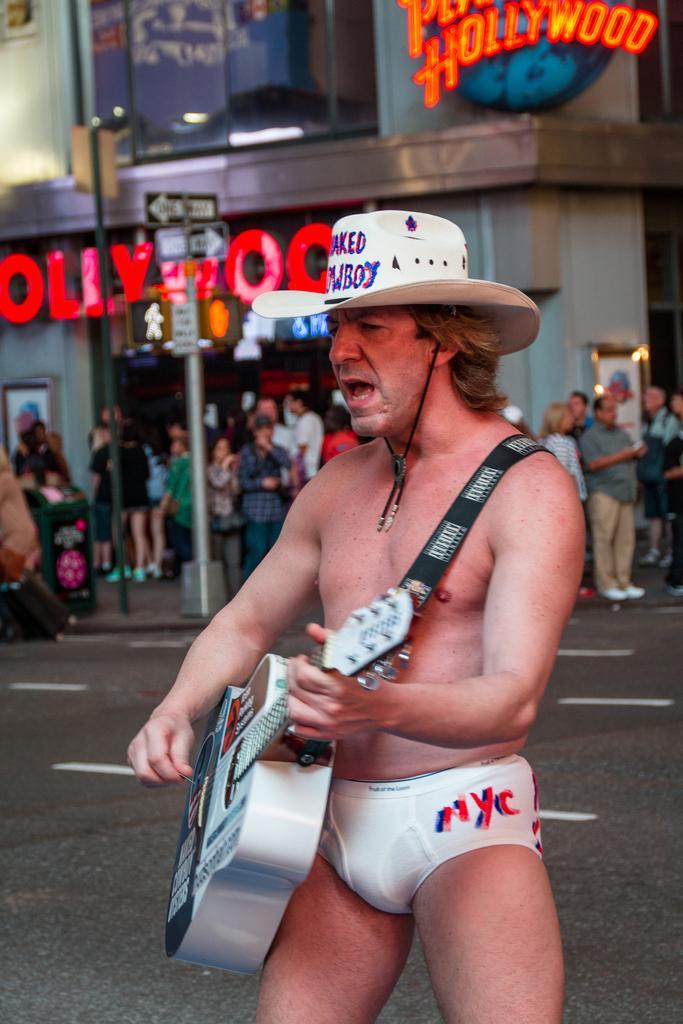In one or two sentences, can you explain what this image depicts? There is a man standing and playing guitar and wore hat. In the background we can see people, board on pole, building, hoarding and road. 